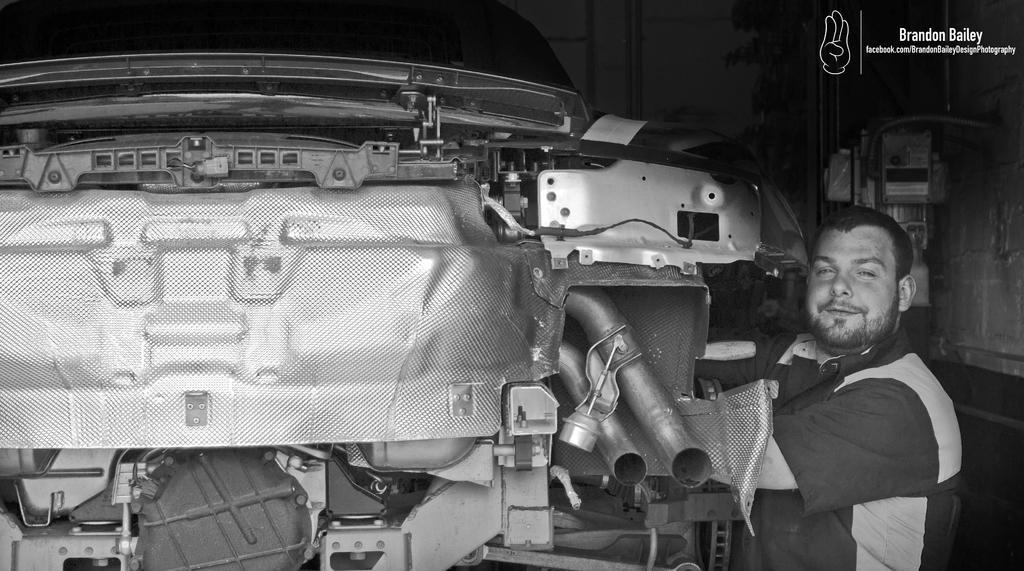How would you summarize this image in a sentence or two? There is a man standing and smiling and we can see vehicle. Background it is dark and we can see object and wall. 